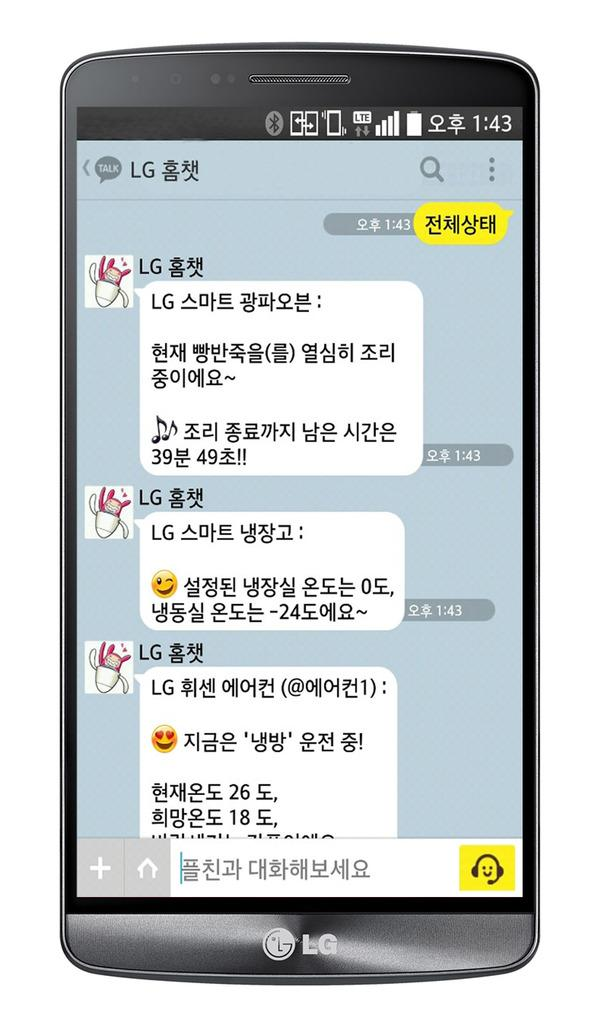<image>
Share a concise interpretation of the image provided. A phone with Korean characters displaying a time of 1:43 